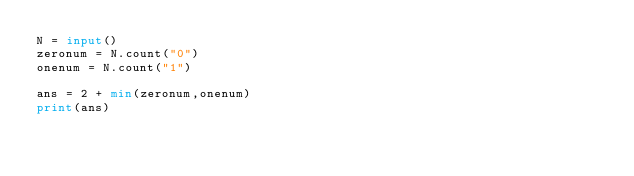Convert code to text. <code><loc_0><loc_0><loc_500><loc_500><_Python_>N = input()
zeronum = N.count("0")
onenum = N.count("1")

ans = 2 + min(zeronum,onenum)
print(ans)
</code> 